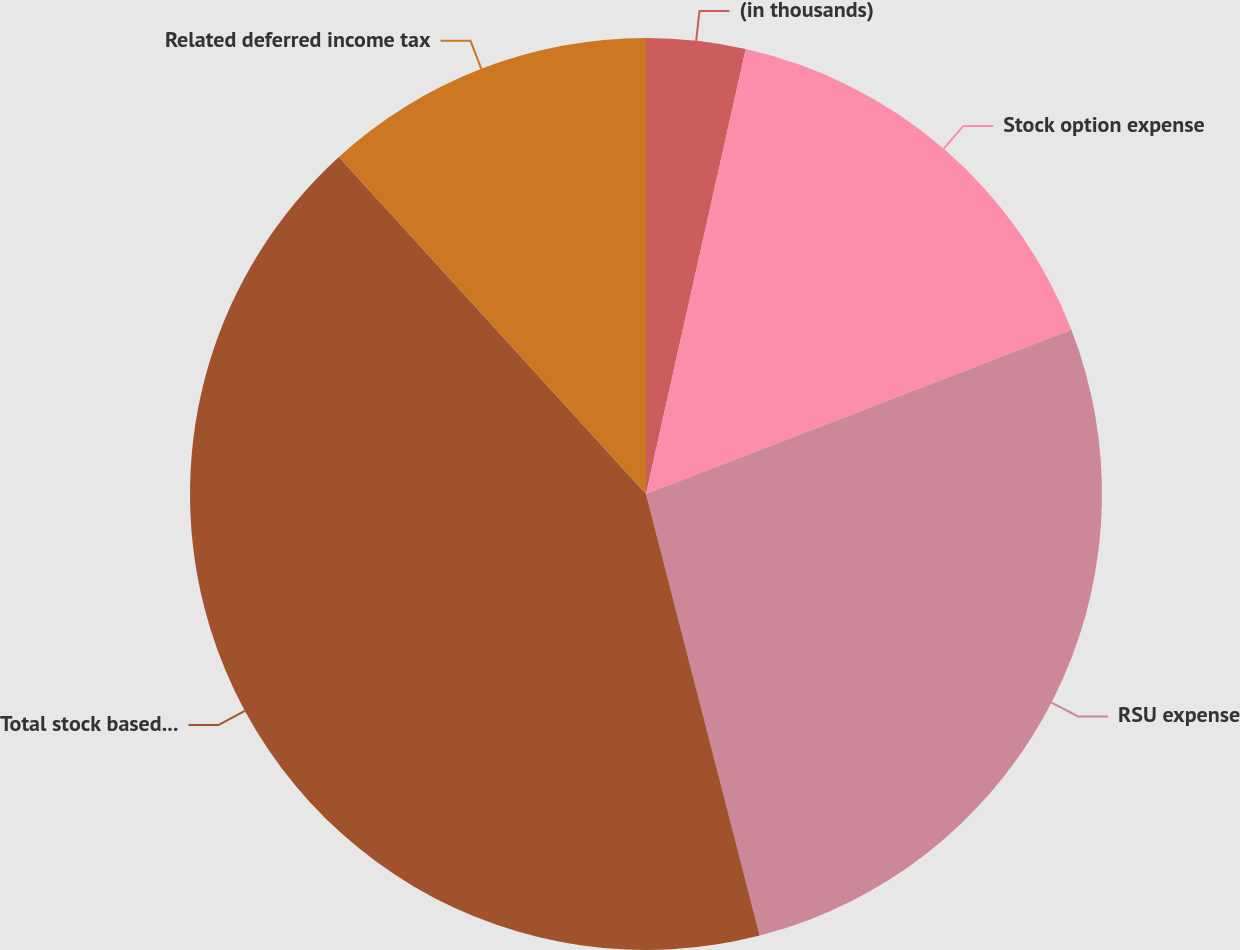Convert chart. <chart><loc_0><loc_0><loc_500><loc_500><pie_chart><fcel>(in thousands)<fcel>Stock option expense<fcel>RSU expense<fcel>Total stock based compensation<fcel>Related deferred income tax<nl><fcel>3.51%<fcel>15.63%<fcel>26.85%<fcel>42.25%<fcel>11.76%<nl></chart> 